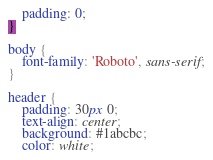Convert code to text. <code><loc_0><loc_0><loc_500><loc_500><_CSS_>    padding: 0;
}

body {
    font-family: 'Roboto', sans-serif;
}

header {
    padding: 30px 0;
    text-align: center;
    background: #1abcbc;
    color: white;</code> 